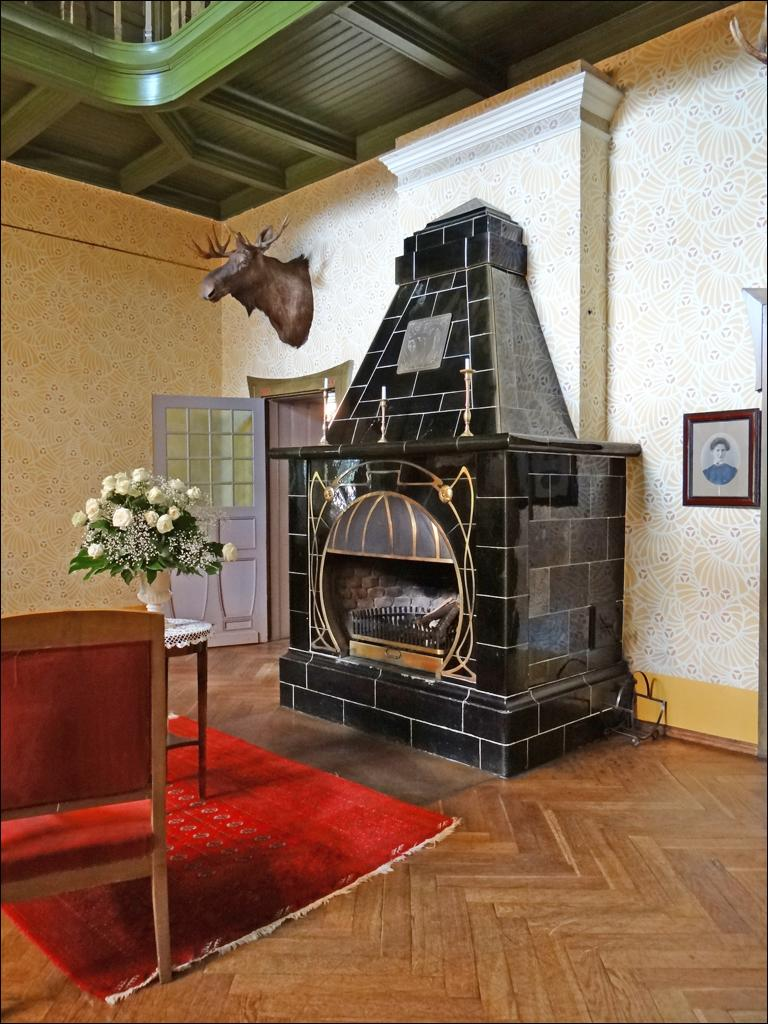What type of living organism can be seen in the image? There is an animal in the image. What type of architectural feature is present in the image? There is a wall in the image. What type of furniture is present in the image? There is a chair in the image. What type of object is present in the image that might be used for eating or working on? There is a table in the image. What type of vegetation is present in the image? There is a plant in the image. What type of snake can be seen slithering on the table in the image? There is no snake present in the image; it only features an animal, a wall, a door, a chair, a table, and a plant. What type of soup is being served in the bowl on the table in the image? There is no soup present in the image; it only features an animal, a wall, a door, a chair, a table, and a plant. 